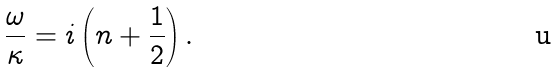Convert formula to latex. <formula><loc_0><loc_0><loc_500><loc_500>\frac { \omega } { \kappa } = i \left ( n + \frac { 1 } { 2 } \right ) .</formula> 